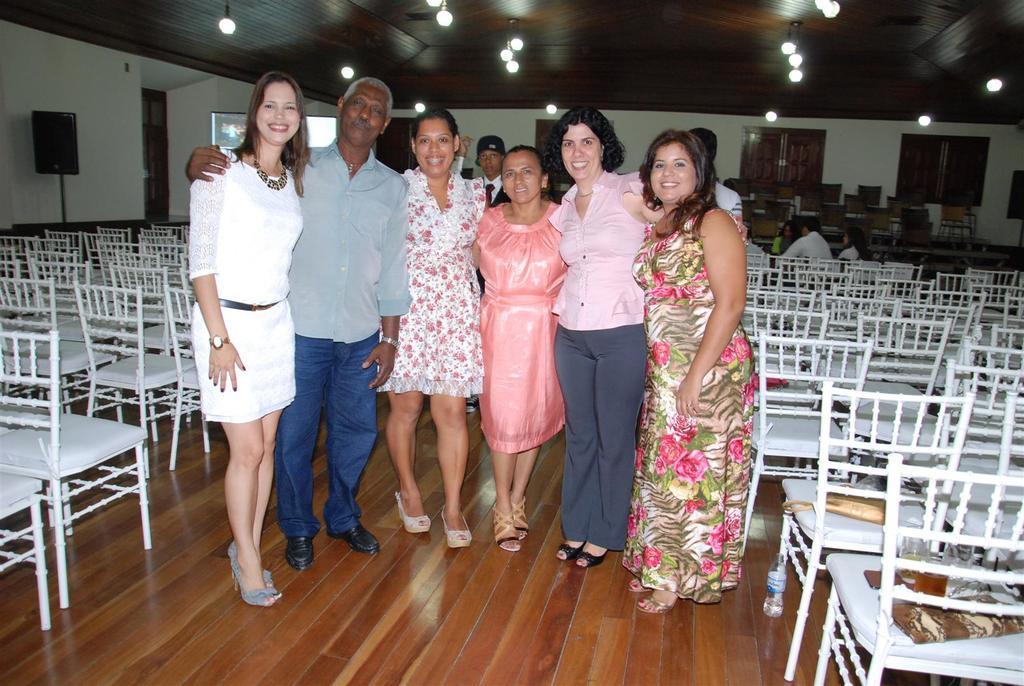Please provide a concise description of this image. In this image on the foreground few people are standing. They all are smiling. In the hall there are many chairs. There are few people in the background. On the ceiling there are lights. There are patches on chairs. Here there is a bottle. This is a speaker. This is a screen. These are the windows. 